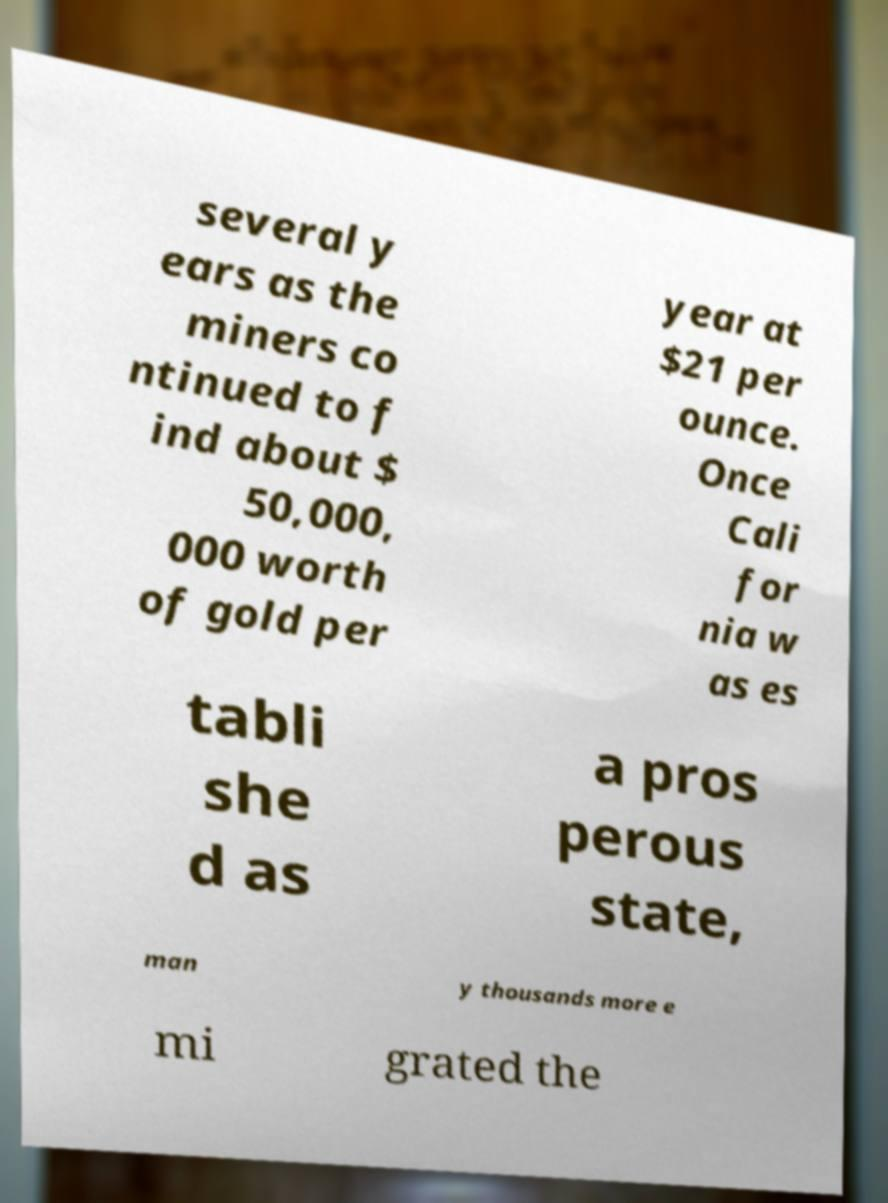Please read and relay the text visible in this image. What does it say? several y ears as the miners co ntinued to f ind about $ 50,000, 000 worth of gold per year at $21 per ounce. Once Cali for nia w as es tabli she d as a pros perous state, man y thousands more e mi grated the 